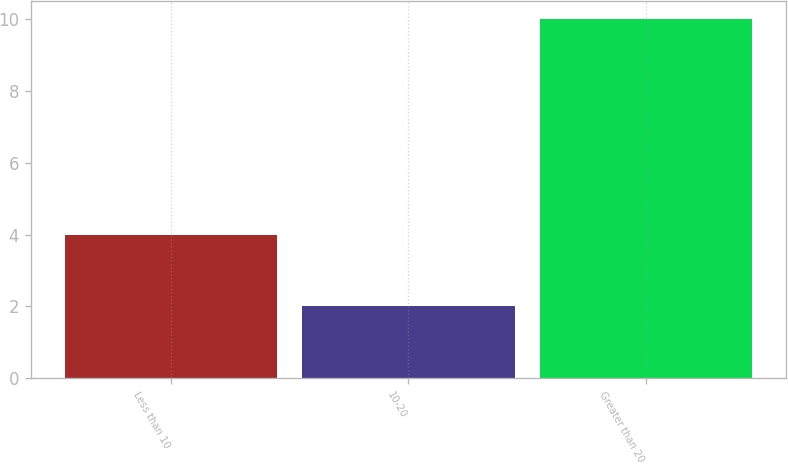<chart> <loc_0><loc_0><loc_500><loc_500><bar_chart><fcel>Less than 10<fcel>10-20<fcel>Greater than 20<nl><fcel>4<fcel>2<fcel>10<nl></chart> 